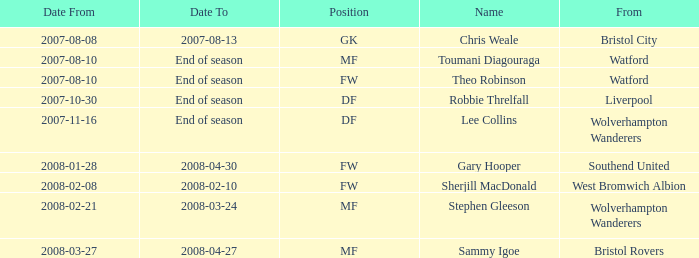What was the name for the row with Date From of 2008-02-21? Stephen Gleeson. 